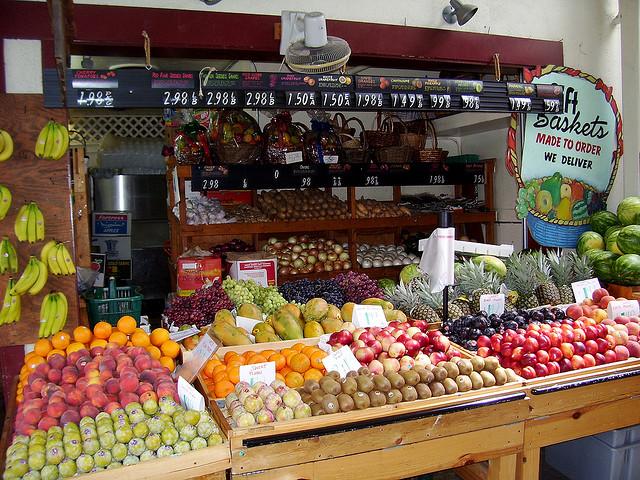Is this a meat section?
Quick response, please. No. What kind of food is being sold?
Quick response, please. Fruit. Are these fruit stands indoors or outdoors?
Give a very brief answer. Outdoors. 